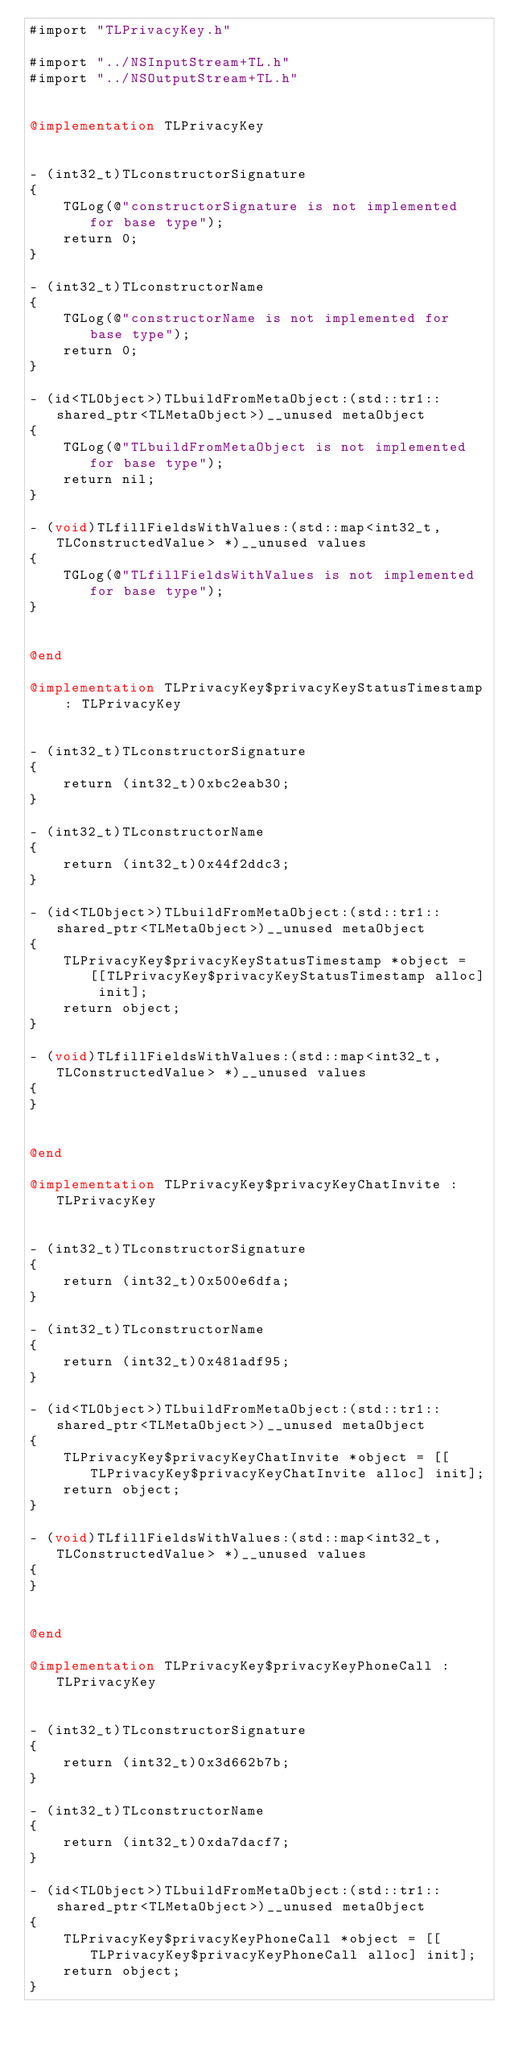<code> <loc_0><loc_0><loc_500><loc_500><_ObjectiveC_>#import "TLPrivacyKey.h"

#import "../NSInputStream+TL.h"
#import "../NSOutputStream+TL.h"


@implementation TLPrivacyKey


- (int32_t)TLconstructorSignature
{
    TGLog(@"constructorSignature is not implemented for base type");
    return 0;
}

- (int32_t)TLconstructorName
{
    TGLog(@"constructorName is not implemented for base type");
    return 0;
}

- (id<TLObject>)TLbuildFromMetaObject:(std::tr1::shared_ptr<TLMetaObject>)__unused metaObject
{
    TGLog(@"TLbuildFromMetaObject is not implemented for base type");
    return nil;
}

- (void)TLfillFieldsWithValues:(std::map<int32_t, TLConstructedValue> *)__unused values
{
    TGLog(@"TLfillFieldsWithValues is not implemented for base type");
}


@end

@implementation TLPrivacyKey$privacyKeyStatusTimestamp : TLPrivacyKey


- (int32_t)TLconstructorSignature
{
    return (int32_t)0xbc2eab30;
}

- (int32_t)TLconstructorName
{
    return (int32_t)0x44f2ddc3;
}

- (id<TLObject>)TLbuildFromMetaObject:(std::tr1::shared_ptr<TLMetaObject>)__unused metaObject
{
    TLPrivacyKey$privacyKeyStatusTimestamp *object = [[TLPrivacyKey$privacyKeyStatusTimestamp alloc] init];
    return object;
}

- (void)TLfillFieldsWithValues:(std::map<int32_t, TLConstructedValue> *)__unused values
{
}


@end

@implementation TLPrivacyKey$privacyKeyChatInvite : TLPrivacyKey


- (int32_t)TLconstructorSignature
{
    return (int32_t)0x500e6dfa;
}

- (int32_t)TLconstructorName
{
    return (int32_t)0x481adf95;
}

- (id<TLObject>)TLbuildFromMetaObject:(std::tr1::shared_ptr<TLMetaObject>)__unused metaObject
{
    TLPrivacyKey$privacyKeyChatInvite *object = [[TLPrivacyKey$privacyKeyChatInvite alloc] init];
    return object;
}

- (void)TLfillFieldsWithValues:(std::map<int32_t, TLConstructedValue> *)__unused values
{
}


@end

@implementation TLPrivacyKey$privacyKeyPhoneCall : TLPrivacyKey


- (int32_t)TLconstructorSignature
{
    return (int32_t)0x3d662b7b;
}

- (int32_t)TLconstructorName
{
    return (int32_t)0xda7dacf7;
}

- (id<TLObject>)TLbuildFromMetaObject:(std::tr1::shared_ptr<TLMetaObject>)__unused metaObject
{
    TLPrivacyKey$privacyKeyPhoneCall *object = [[TLPrivacyKey$privacyKeyPhoneCall alloc] init];
    return object;
}
</code> 